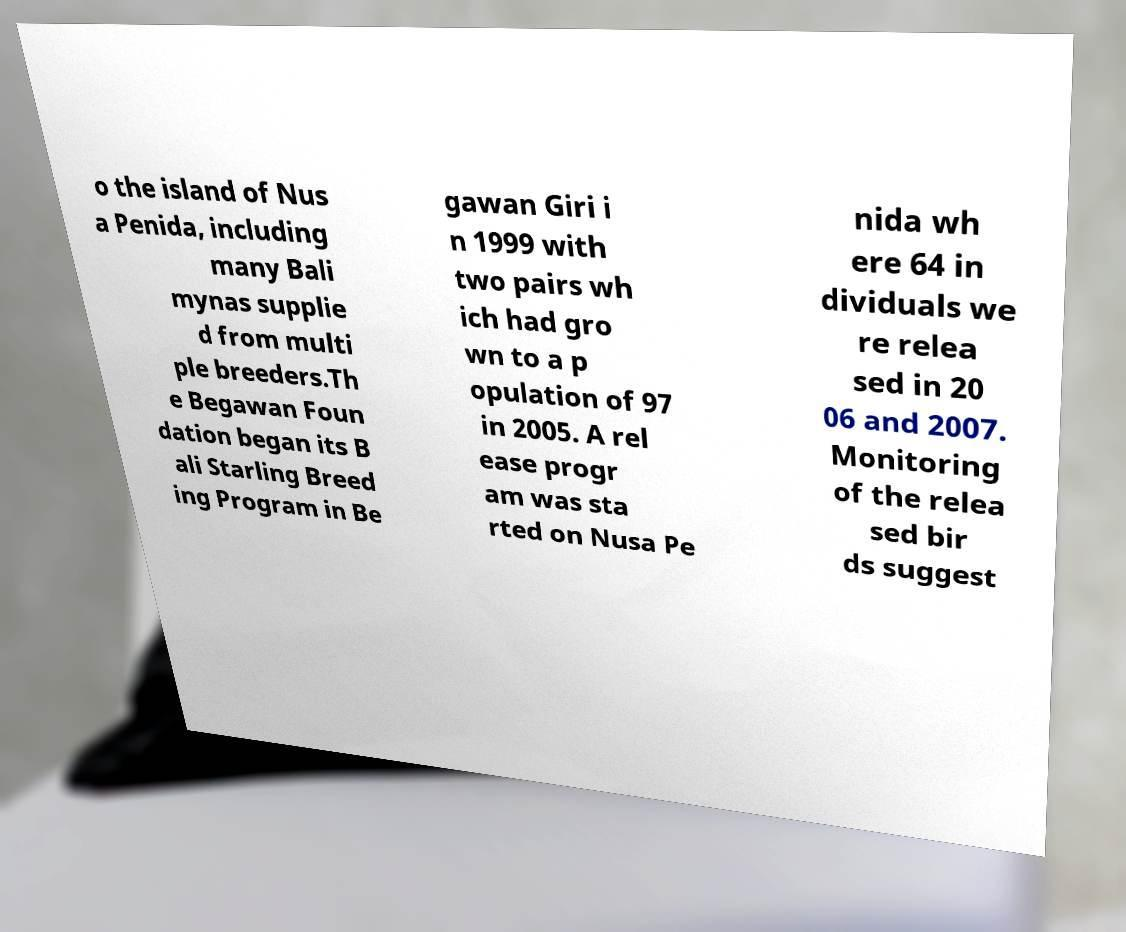For documentation purposes, I need the text within this image transcribed. Could you provide that? o the island of Nus a Penida, including many Bali mynas supplie d from multi ple breeders.Th e Begawan Foun dation began its B ali Starling Breed ing Program in Be gawan Giri i n 1999 with two pairs wh ich had gro wn to a p opulation of 97 in 2005. A rel ease progr am was sta rted on Nusa Pe nida wh ere 64 in dividuals we re relea sed in 20 06 and 2007. Monitoring of the relea sed bir ds suggest 